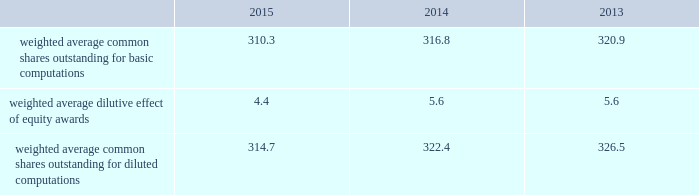2015 and 2014 was $ 1.5 billion and $ 1.3 billion .
The aggregate notional amount of our outstanding foreign currency hedges at december 31 , 2015 and 2014 was $ 4.1 billion and $ 804 million .
Derivative instruments did not have a material impact on net earnings and comprehensive income during 2015 , 2014 and 2013 .
Substantially all of our derivatives are designated for hedge accounting .
See note 16 for more information on the fair value measurements related to our derivative instruments .
Recent accounting pronouncements 2013 in may 2014 , the fasb issued a new standard that will change the way we recognize revenue and significantly expand the disclosure requirements for revenue arrangements .
On july 9 , 2015 , the fasb approved a one-year deferral of the effective date of the standard to 2018 for public companies , with an option that would permit companies to adopt the standard in 2017 .
Early adoption prior to 2017 is not permitted .
The new standard may be adopted either retrospectively or on a modified retrospective basis whereby the new standard would be applied to new contracts and existing contracts with remaining performance obligations as of the effective date , with a cumulative catch-up adjustment recorded to beginning retained earnings at the effective date for existing contracts with remaining performance obligations .
In addition , the fasb is contemplating making additional changes to certain elements of the new standard .
We are currently evaluating the methods of adoption allowed by the new standard and the effect the standard is expected to have on our consolidated financial statements and related disclosures .
As the new standard will supersede substantially all existing revenue guidance affecting us under gaap , it could impact revenue and cost recognition on thousands of contracts across all our business segments , in addition to our business processes and our information technology systems .
As a result , our evaluation of the effect of the new standard will extend over future periods .
In september 2015 , the fasb issued a new standard that simplifies the accounting for adjustments made to preliminary amounts recognized in a business combination by eliminating the requirement to retrospectively account for those adjustments .
Instead , adjustments will be recognized in the period in which the adjustments are determined , including the effect on earnings of any amounts that would have been recorded in previous periods if the accounting had been completed at the acquisition date .
We adopted the standard on january 1 , 2016 and will prospectively apply the standard to business combination adjustments identified after the date of adoption .
In november 2015 , the fasb issued a new standard that simplifies the presentation of deferred income taxes and requires that deferred tax assets and liabilities , as well as any related valuation allowance , be classified as noncurrent in our consolidated balance sheets .
The standard is effective january 1 , 2017 , with early adoption permitted .
The standard may be applied either prospectively from the date of adoption or retrospectively to all prior periods presented .
We are currently evaluating when we will adopt the standard and the method of adoption .
Note 2 2013 earnings per share the weighted average number of shares outstanding used to compute earnings per common share were as follows ( in millions ) : .
We compute basic and diluted earnings per common share by dividing net earnings by the respective weighted average number of common shares outstanding for the periods presented .
Our calculation of diluted earnings per common share also includes the dilutive effects for the assumed vesting of outstanding restricted stock units and exercise of outstanding stock options based on the treasury stock method .
The computation of diluted earnings per common share excluded 2.4 million stock options for the year ended december 31 , 2013 because their inclusion would have been anti-dilutive , primarily due to their exercise prices exceeding the average market prices of our common stock during the respective periods .
There were no anti-dilutive equity awards for the years ended december 31 , 2015 and 2014. .
What was the change in weighted average common shares outstanding for diluted computations from 2013 to 2014 , in millions? 
Computations: (322.4 - 326.5)
Answer: -4.1. 